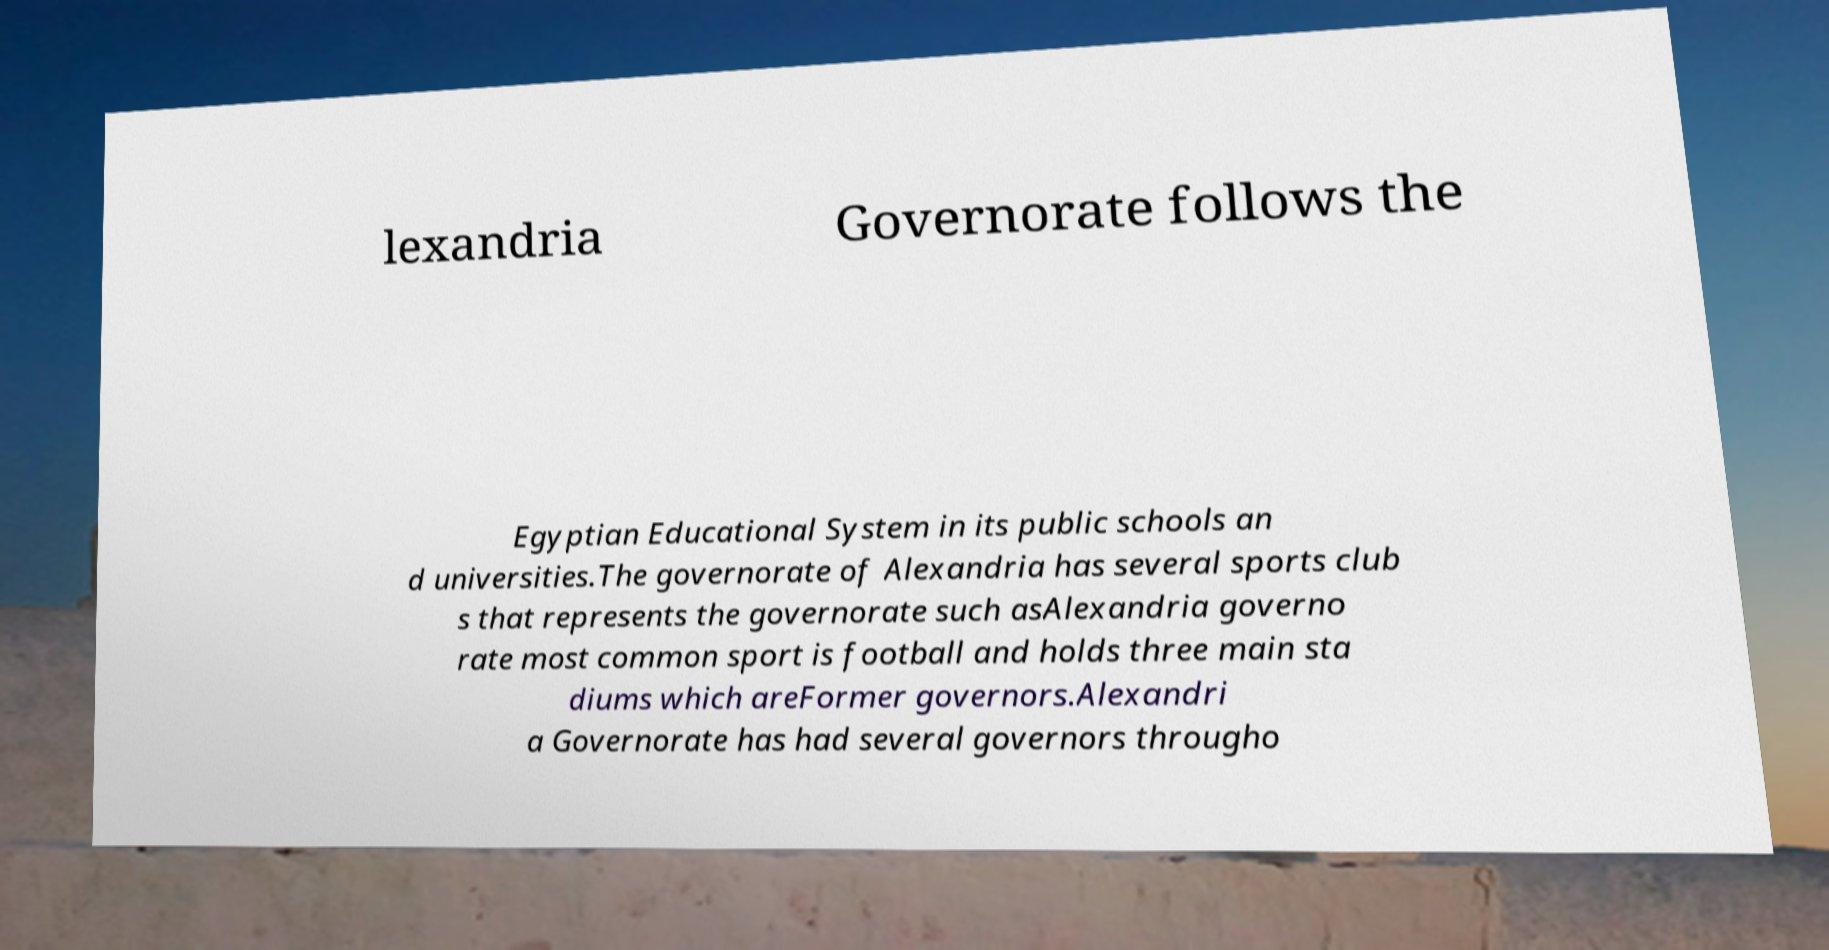Please read and relay the text visible in this image. What does it say? lexandria Governorate follows the Egyptian Educational System in its public schools an d universities.The governorate of Alexandria has several sports club s that represents the governorate such asAlexandria governo rate most common sport is football and holds three main sta diums which areFormer governors.Alexandri a Governorate has had several governors througho 